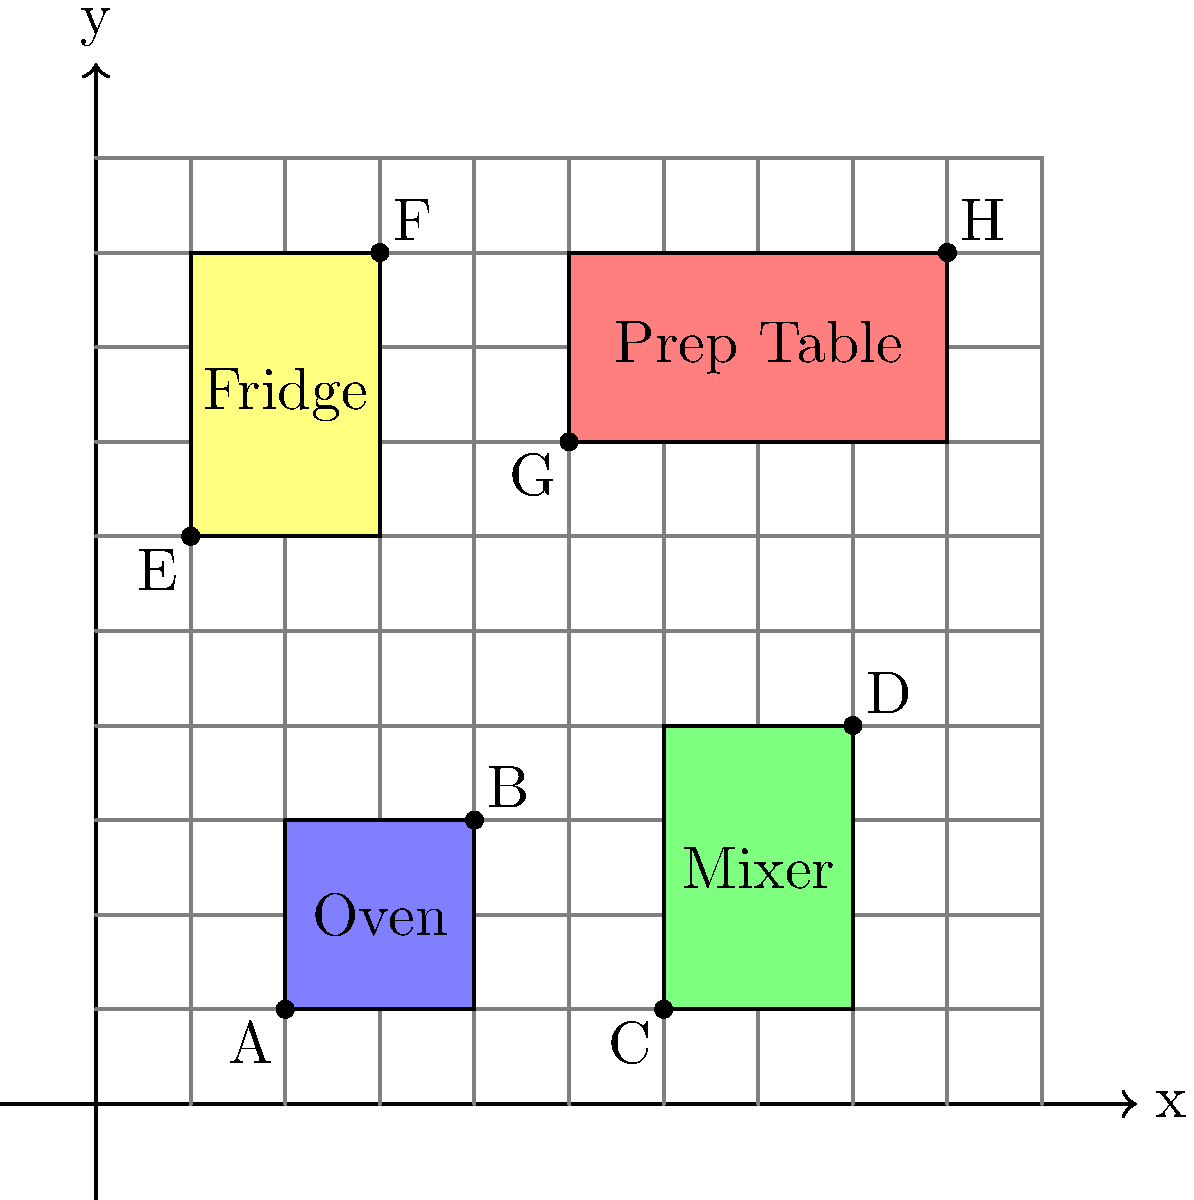In your bakery, you need to calculate the total floor space occupied by your equipment to ensure optimal placement. The coordinate grid represents your bakery floor, where each unit equals 1 square meter. Given the equipment placement shown in the diagram, calculate the total area occupied by all four pieces of equipment (Oven, Mixer, Fridge, and Prep Table). Express your answer in square meters. To calculate the total area occupied by the equipment, we need to find the area of each piece and then sum them up. Let's go through this step-by-step:

1. Oven (blue rectangle):
   Coordinates: A(2,1) to B(4,3)
   Width = 4 - 2 = 2 units
   Height = 3 - 1 = 2 units
   Area = 2 * 2 = 4 sq meters

2. Mixer (green rectangle):
   Coordinates: C(6,1) to D(8,4)
   Width = 8 - 6 = 2 units
   Height = 4 - 1 = 3 units
   Area = 2 * 3 = 6 sq meters

3. Fridge (yellow rectangle):
   Coordinates: E(1,6) to F(3,9)
   Width = 3 - 1 = 2 units
   Height = 9 - 6 = 3 units
   Area = 2 * 3 = 6 sq meters

4. Prep Table (red rectangle):
   Coordinates: G(5,7) to H(9,9)
   Width = 9 - 5 = 4 units
   Height = 9 - 7 = 2 units
   Area = 4 * 2 = 8 sq meters

Total area = Oven + Mixer + Fridge + Prep Table
           = 4 + 6 + 6 + 8
           = 24 sq meters

Therefore, the total area occupied by all four pieces of equipment is 24 square meters.
Answer: 24 sq meters 